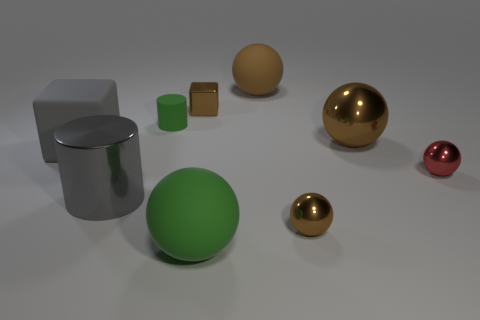Is there a large brown matte thing of the same shape as the large brown metallic object?
Provide a succinct answer. Yes. There is a tiny brown metal thing left of the brown ball that is in front of the tiny red sphere; what is its shape?
Ensure brevity in your answer.  Cube. There is a tiny green rubber thing; what shape is it?
Provide a short and direct response. Cylinder. What is the material of the cylinder behind the brown metallic sphere that is behind the tiny brown thing right of the large green rubber thing?
Give a very brief answer. Rubber. What number of other objects are there of the same material as the red sphere?
Ensure brevity in your answer.  4. There is a cylinder that is on the left side of the tiny green matte thing; what number of large things are left of it?
Your response must be concise. 1. How many balls are either big gray rubber things or small rubber things?
Offer a very short reply. 0. There is a small thing that is both in front of the rubber block and behind the large gray cylinder; what is its color?
Provide a succinct answer. Red. Is there any other thing of the same color as the big cube?
Offer a very short reply. Yes. What is the color of the big metal object that is to the right of the tiny brown object to the left of the large brown rubber object?
Make the answer very short. Brown. 